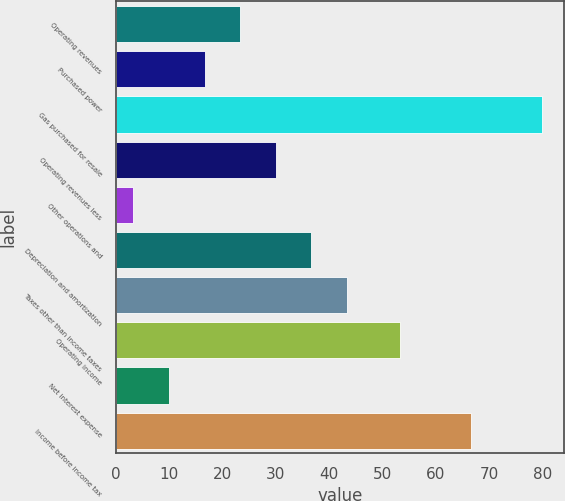Convert chart to OTSL. <chart><loc_0><loc_0><loc_500><loc_500><bar_chart><fcel>Operating revenues<fcel>Purchased power<fcel>Gas purchased for resale<fcel>Operating revenues less<fcel>Other operations and<fcel>Depreciation and amortization<fcel>Taxes other than income taxes<fcel>Operating income<fcel>Net interest expense<fcel>Income before income tax<nl><fcel>23.31<fcel>16.64<fcel>79.98<fcel>29.98<fcel>3.3<fcel>36.65<fcel>43.32<fcel>53.3<fcel>9.97<fcel>66.64<nl></chart> 